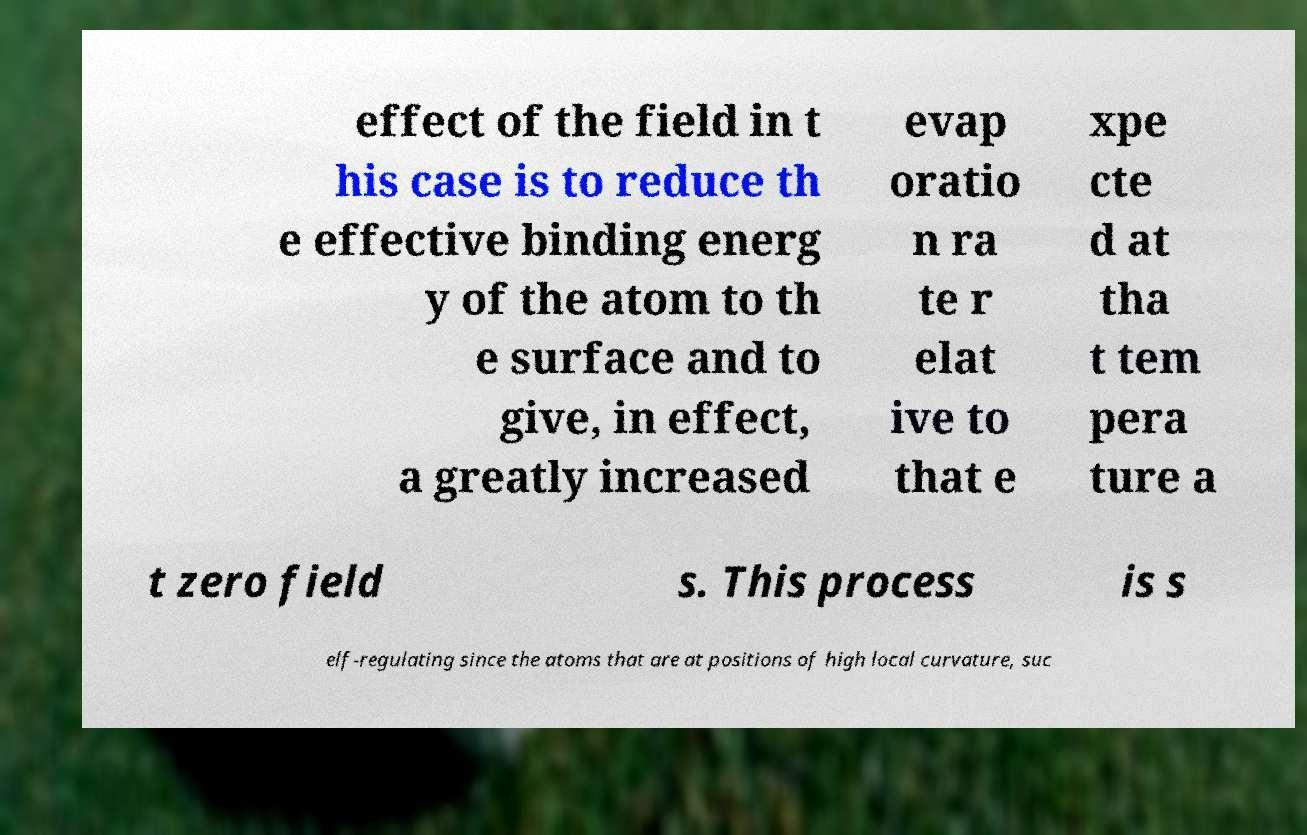Please read and relay the text visible in this image. What does it say? effect of the field in t his case is to reduce th e effective binding energ y of the atom to th e surface and to give, in effect, a greatly increased evap oratio n ra te r elat ive to that e xpe cte d at tha t tem pera ture a t zero field s. This process is s elf-regulating since the atoms that are at positions of high local curvature, suc 